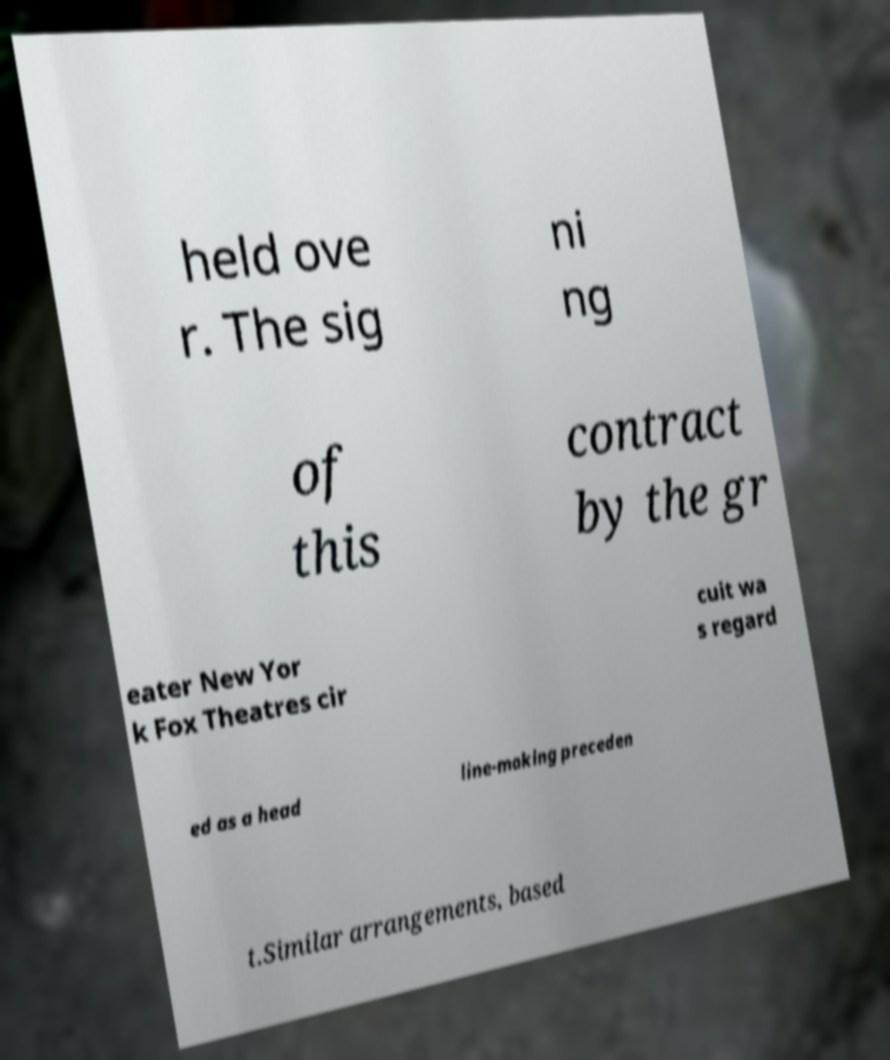What messages or text are displayed in this image? I need them in a readable, typed format. held ove r. The sig ni ng of this contract by the gr eater New Yor k Fox Theatres cir cuit wa s regard ed as a head line-making preceden t.Similar arrangements, based 